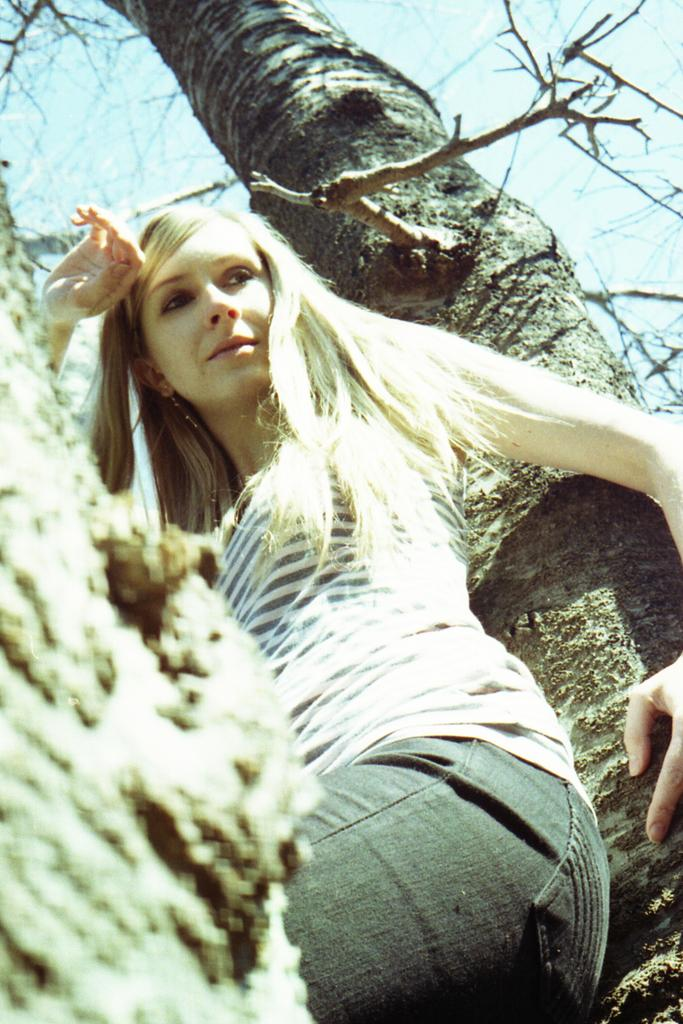What is the main subject in the foreground of the image? There is a person sitting on a tree in the foreground of the image. Can you describe the background of the image? There is a tree in the background of the image. How many pigs can be seen swimming in the sea in the image? There are no pigs or sea present in the image; it features a person sitting on a tree in the foreground and a tree in the background. 